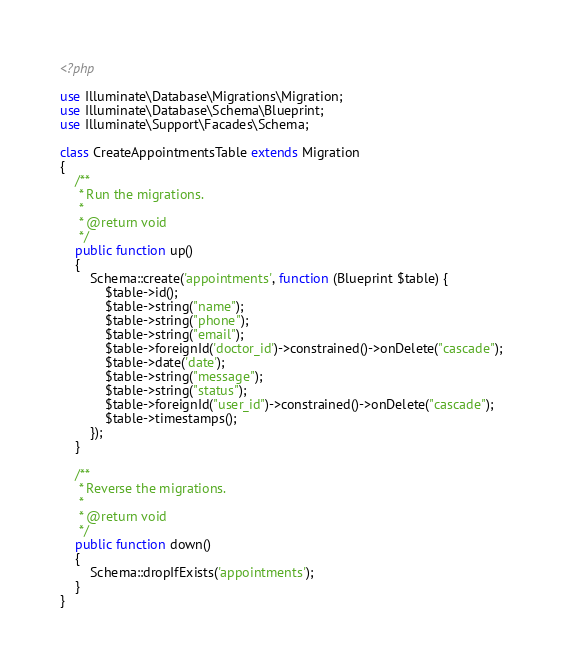Convert code to text. <code><loc_0><loc_0><loc_500><loc_500><_PHP_><?php

use Illuminate\Database\Migrations\Migration;
use Illuminate\Database\Schema\Blueprint;
use Illuminate\Support\Facades\Schema;

class CreateAppointmentsTable extends Migration
{
    /**
     * Run the migrations.
     *
     * @return void
     */
    public function up()
    {
        Schema::create('appointments', function (Blueprint $table) {
            $table->id();
            $table->string("name");
            $table->string("phone");
            $table->string("email");
            $table->foreignId('doctor_id')->constrained()->onDelete("cascade");
            $table->date('date');
            $table->string("message");
            $table->string("status");
            $table->foreignId("user_id")->constrained()->onDelete("cascade");
            $table->timestamps();
        });
    }

    /**
     * Reverse the migrations.
     *
     * @return void
     */
    public function down()
    {
        Schema::dropIfExists('appointments');
    }
}
</code> 